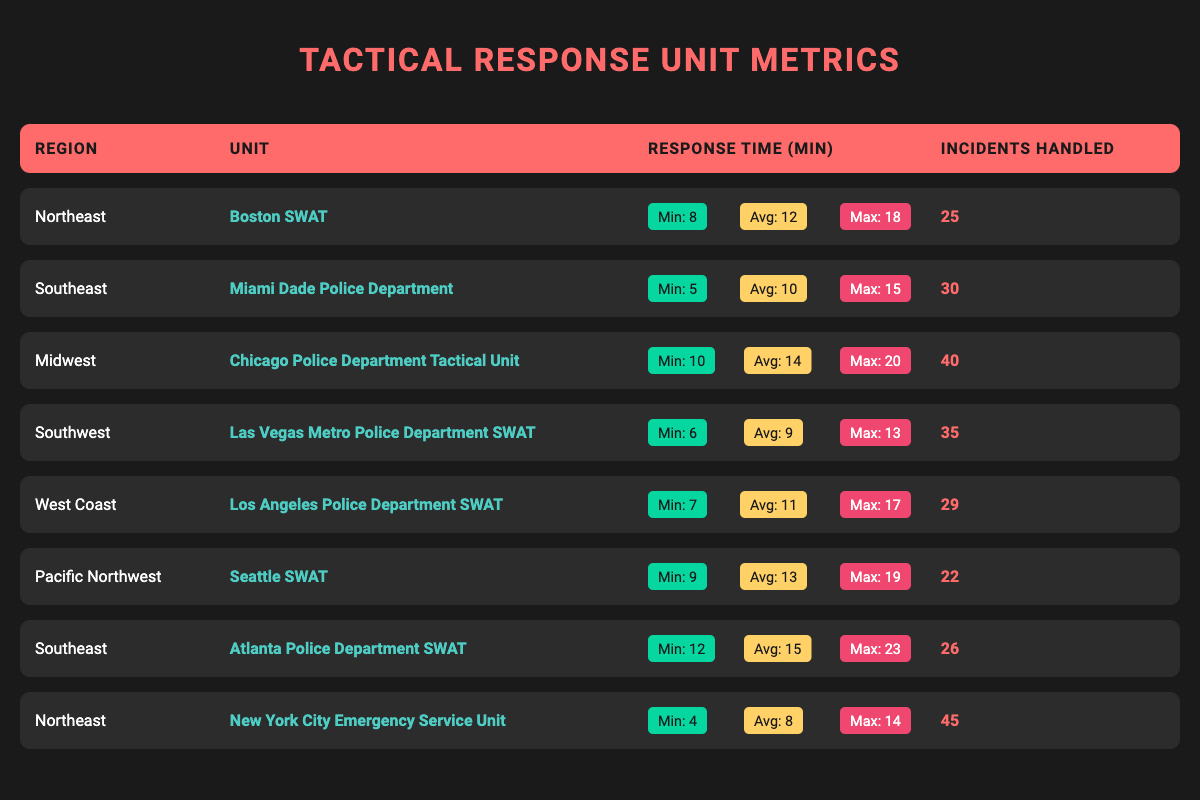What is the average response time for the Boston SWAT unit? The average response time for the Boston SWAT unit is provided in the table as 12 minutes.
Answer: 12 minutes Which unit has the highest average response time? The Chicago Police Department Tactical Unit has the highest average response time at 14 minutes compared to other units listed.
Answer: Chicago Police Department Tactical Unit How many incidents did the New York City Emergency Service Unit handle? The table shows the New York City Emergency Service Unit handled 45 incidents.
Answer: 45 incidents What is the max response time for the Miami Dade Police Department? The maximum response time for Miami Dade Police Department is listed in the table as 15 minutes.
Answer: 15 minutes Which region has the lowest minimum response time? The lowest minimum response time is 4 minutes, which is from the New York City Emergency Service Unit in the Northeast region.
Answer: Northeast What is the average response time across all units? To find the average response time, sum all average response times (12 + 10 + 14 + 9 + 11 + 13 + 15 + 8 = 97) and divide by the number of units (8). The total is 97/8 = 12.125 minutes, rounding to 12 minutes.
Answer: 12 minutes Are any units in the Southeast region better than the Southwest region in terms of average response time? The average response time for Miami Dade Police Department (10 minutes) is better than Las Vegas Metro Police Department SWAT (9 minutes) in the Southwest region, while Atlanta Police Department SWAT (15 minutes) is worse than Las Vegas. So, 10 minutes is better than 9 minutes.
Answer: Yes How many more incidents did the Chicago Police Department handle than the Seattle SWAT? The Chicago Police Department handled 40 incidents while the Seattle SWAT handled 22. The difference is 40 - 22 = 18 incidents.
Answer: 18 incidents Is the average response time of the Atlanta Police Department SWAT unit longer than that of the Las Vegas Metro Police Department SWAT? The average response time of Atlanta Police Department SWAT is 15 minutes, which is longer than the average response time of Las Vegas Metro Police Department SWAT at 9 minutes.
Answer: Yes In which unit was the minimum response time recorded as 6 minutes? The Las Vegas Metro Police Department SWAT unit has a recorded minimum response time of 6 minutes.
Answer: Las Vegas Metro Police Department SWAT 